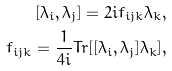Convert formula to latex. <formula><loc_0><loc_0><loc_500><loc_500>[ \lambda _ { i } , \lambda _ { j } ] = 2 i f _ { i j k } \lambda _ { k } , \\ f _ { i j k } = \frac { 1 } { 4 i } T r [ [ \lambda _ { i } , \lambda _ { j } ] \lambda _ { k } ] ,</formula> 